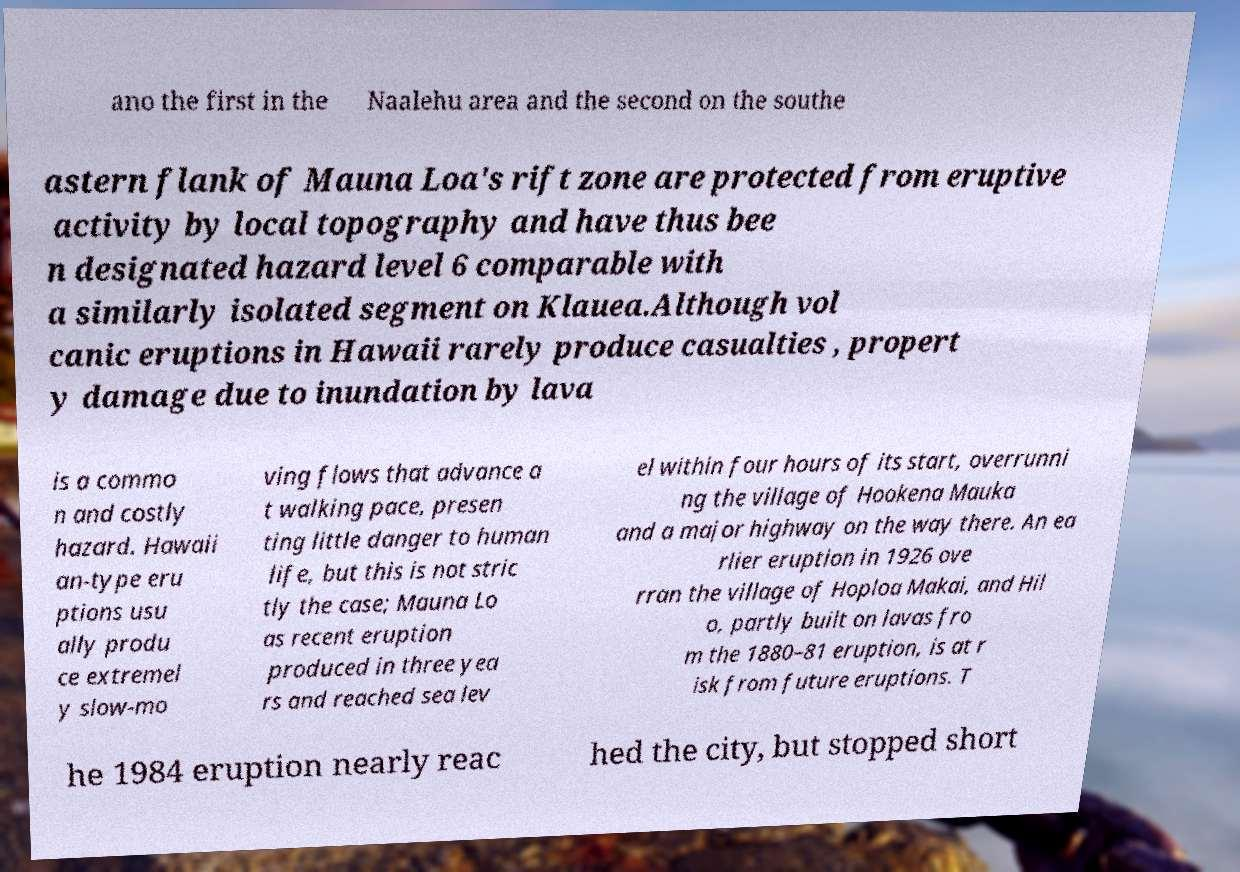Can you accurately transcribe the text from the provided image for me? ano the first in the Naalehu area and the second on the southe astern flank of Mauna Loa's rift zone are protected from eruptive activity by local topography and have thus bee n designated hazard level 6 comparable with a similarly isolated segment on Klauea.Although vol canic eruptions in Hawaii rarely produce casualties , propert y damage due to inundation by lava is a commo n and costly hazard. Hawaii an-type eru ptions usu ally produ ce extremel y slow-mo ving flows that advance a t walking pace, presen ting little danger to human life, but this is not stric tly the case; Mauna Lo as recent eruption produced in three yea rs and reached sea lev el within four hours of its start, overrunni ng the village of Hookena Mauka and a major highway on the way there. An ea rlier eruption in 1926 ove rran the village of Hoploa Makai, and Hil o, partly built on lavas fro m the 1880–81 eruption, is at r isk from future eruptions. T he 1984 eruption nearly reac hed the city, but stopped short 